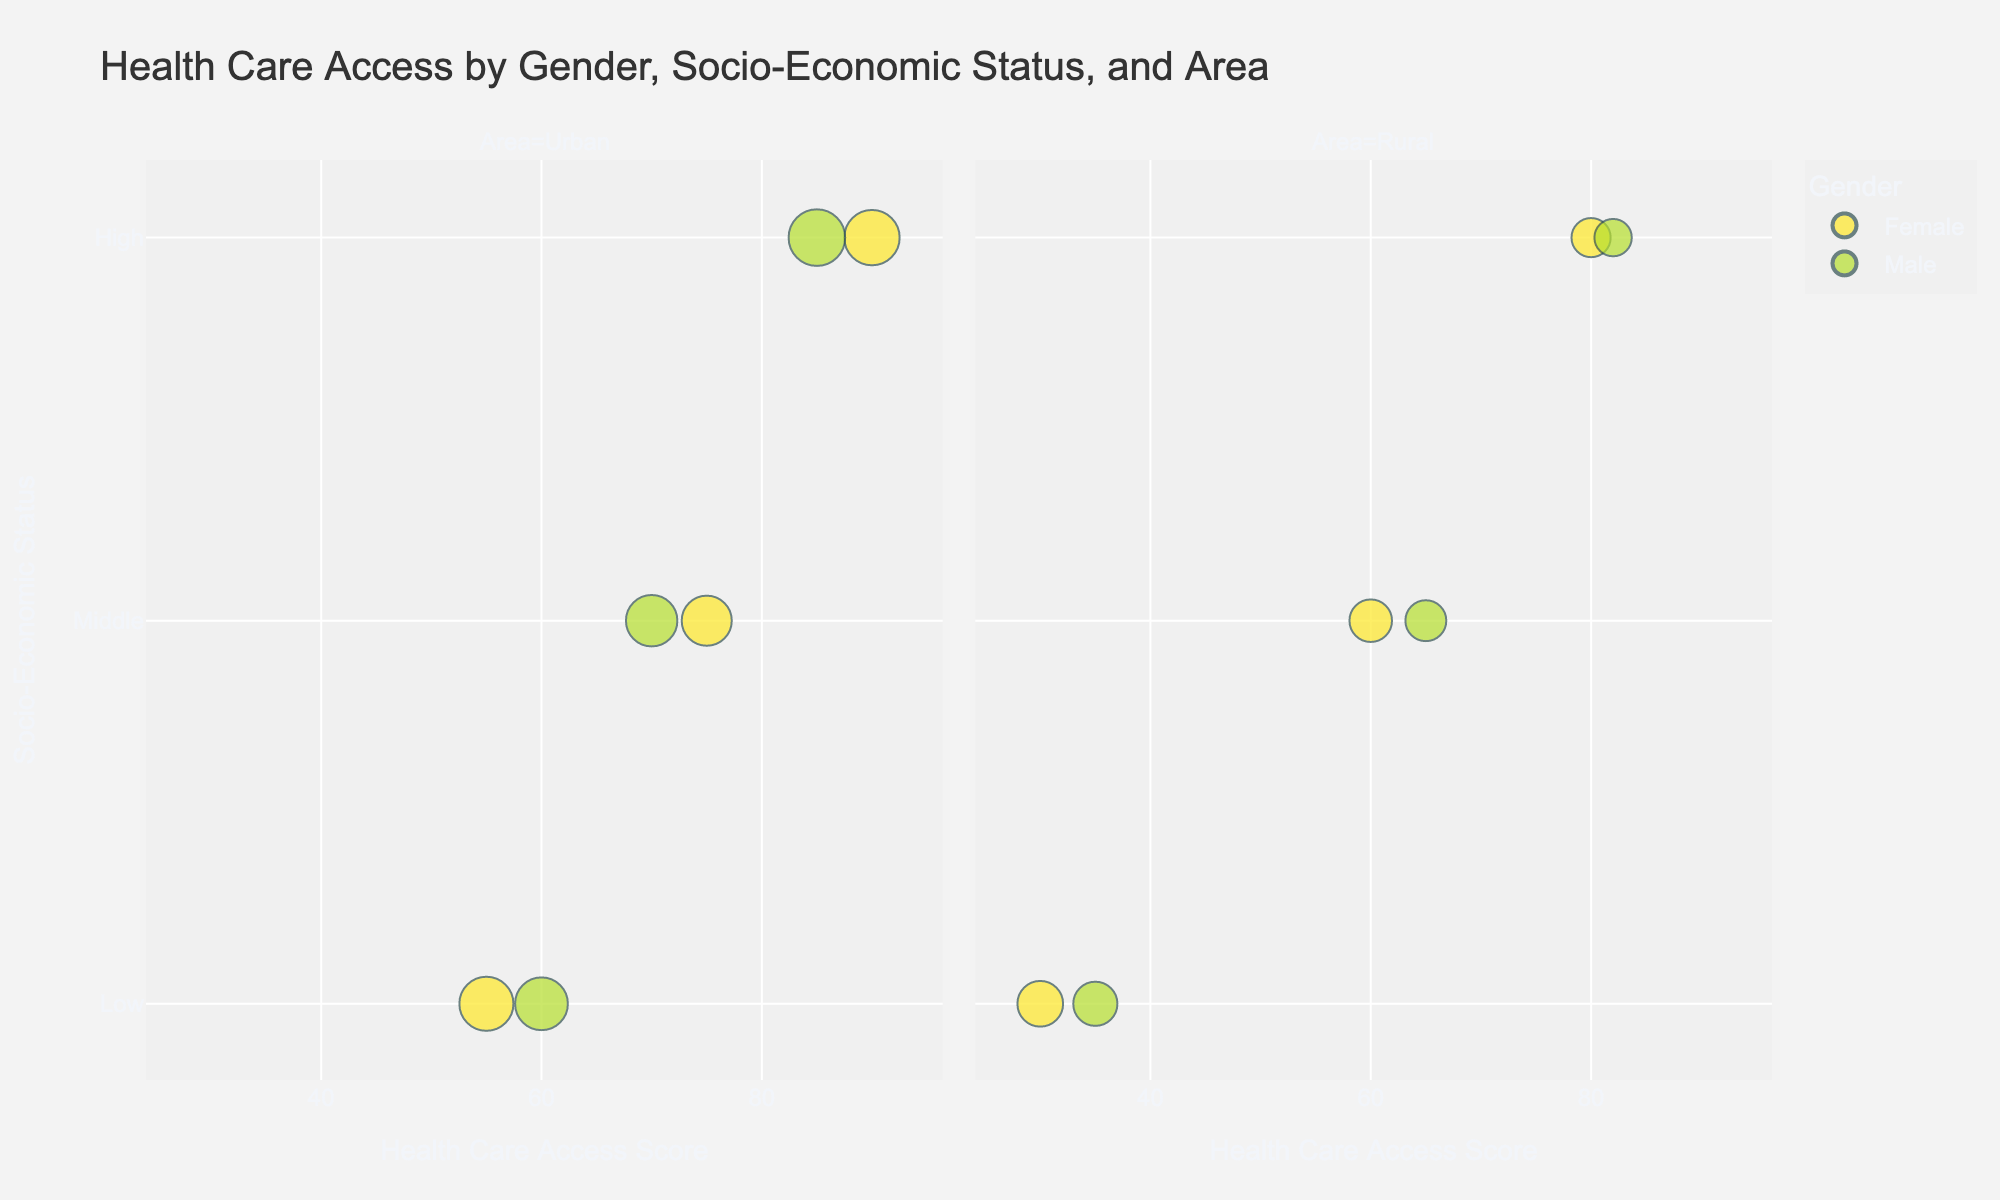What's the title of the figure? The title is displayed at the top of the bubble chart. It summarizes the main focus of the chart, which is about health care access by gender, socio-economic status, and area.
Answer: Health Care Access by Gender, Socio-Economic Status, and Area How many data points are there in the Urban area? By looking at the Urban facet of the bubble chart, we count the number of bubbles indicating the data points. For the Urban area, there are three genders and three socio-economic statuses, each corresponding to a bubble.
Answer: 6 In which area do females with high socio-economic status have a higher access score? To answer this, check the AccessScore for females with high socio-economic status in both Urban and Rural areas. The bubble in the Urban area shows an AccessScore of 90 for this group, while the bubble in the Rural area shows an AccessScore of 80.
Answer: Urban What is the combined population of males in the urban area? Add the population values of all male data points in the Urban area. These values are 2000, 1900, and 2300.
Answer: 6200 Which gender has a higher health care access score in the rural area across all socio-economic statuses? Compare the AccessScore of females and males in the rural area across low, middle, and high socio-economic statuses. Summing the AccessScores for females gives 30 + 60 + 80 = 170, and for males, it is 35 + 65 + 82 = 182. Males have a higher sum.
Answer: Male Which group has the smallest bubble in the chart, and what does this represent? The smallest bubble represents the group with the smallest population. This can be observed by visually comparing the size of the bubbles. The smallest bubble is for High socio-economic status Males in the Rural area with a population of 1000.
Answer: Males, High socio-economic status, Rural area What is the difference in health care access scores between males with low socio-economic status in Urban and Rural areas? Subtract the AccessScore of males in the rural area from that of males in the urban area for low socio-economic status. The scores are 60 (Urban) and 35 (Rural), so the difference is 60 - 35.
Answer: 25 Is there a correlation between socio-economic status and health care access score in the urban area for females? Observe the trend in AccessScores for females across low, middle, and high socio-economic statuses in the urban area. The scores increase from 55 (low) to 75 (middle) to 90 (high), indicating a positive correlation.
Answer: Yes Which socio-economic status group has the largest disparity in access scores between urban and rural areas for females? Calculate the difference between urban and rural AccessScores for each socio-economic status group of females. For low: 55 - 30 = 25, for middle: 75 - 60 = 15, and for high: 90 - 80 = 10. The low socio-economic status group has the largest disparity.
Answer: Low 